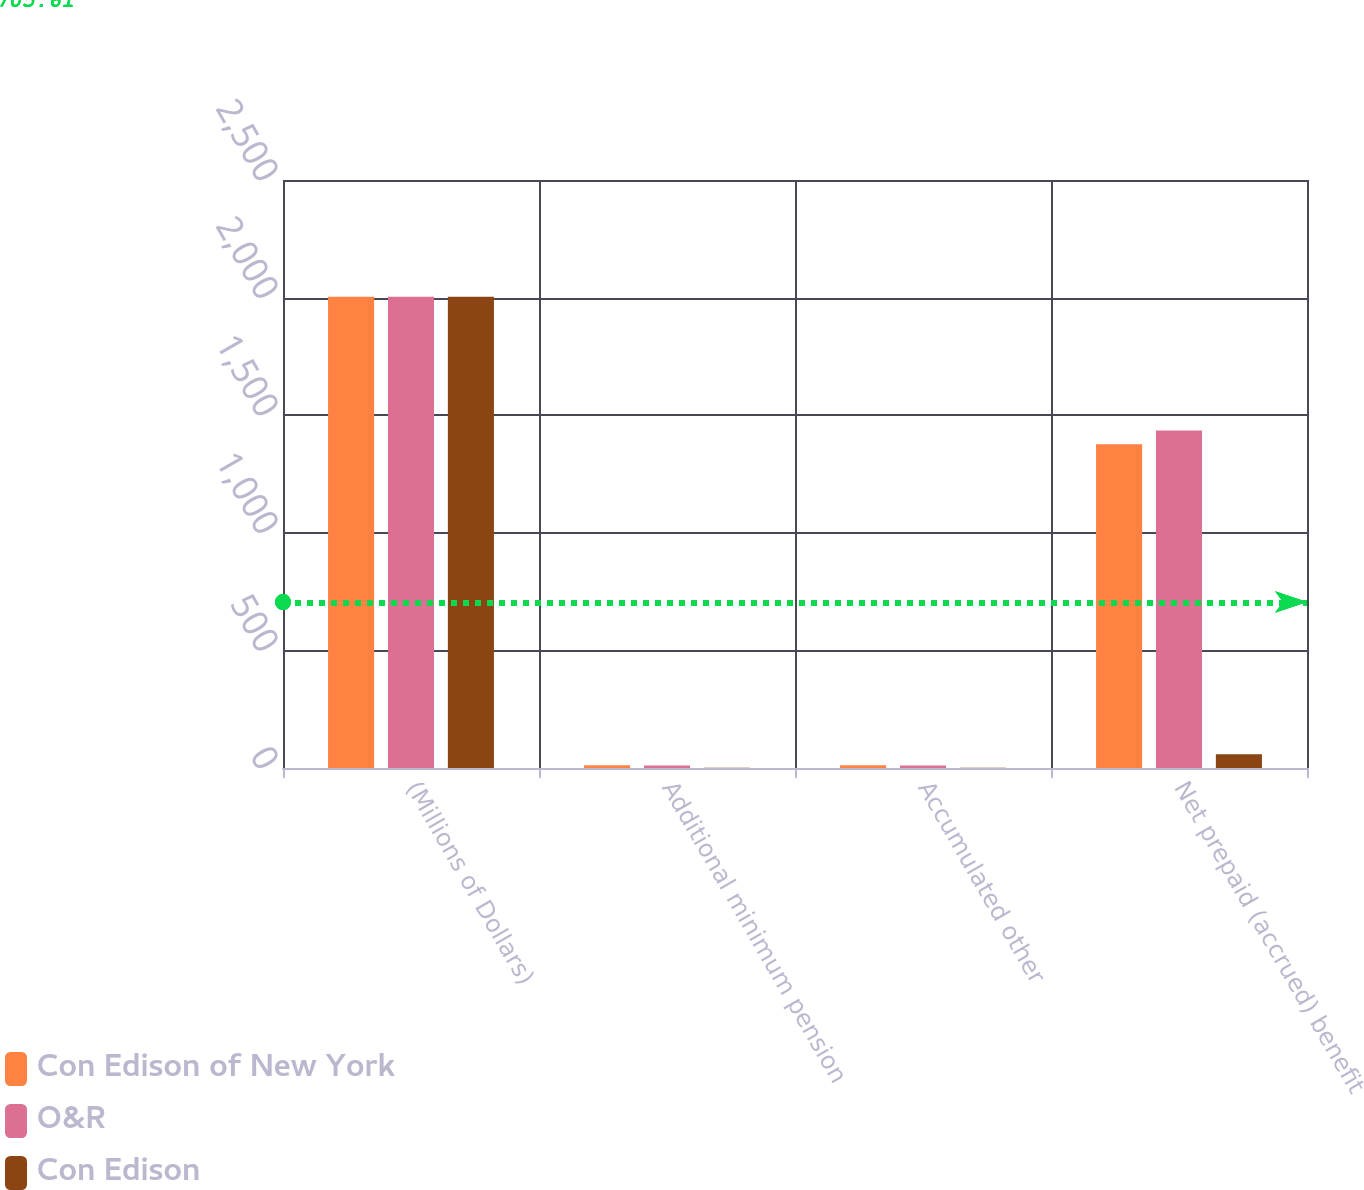Convert chart. <chart><loc_0><loc_0><loc_500><loc_500><stacked_bar_chart><ecel><fcel>(Millions of Dollars)<fcel>Additional minimum pension<fcel>Accumulated other<fcel>Net prepaid (accrued) benefit<nl><fcel>Con Edison of New York<fcel>2004<fcel>12<fcel>12<fcel>1377<nl><fcel>O&R<fcel>2004<fcel>11<fcel>11<fcel>1435<nl><fcel>Con Edison<fcel>2004<fcel>1<fcel>1<fcel>58<nl></chart> 